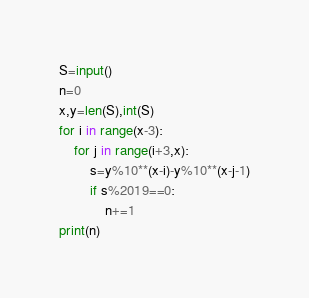Convert code to text. <code><loc_0><loc_0><loc_500><loc_500><_Python_>S=input()
n=0
x,y=len(S),int(S)
for i in range(x-3):
    for j in range(i+3,x):
        s=y%10**(x-i)-y%10**(x-j-1)
        if s%2019==0:
            n+=1
print(n)</code> 